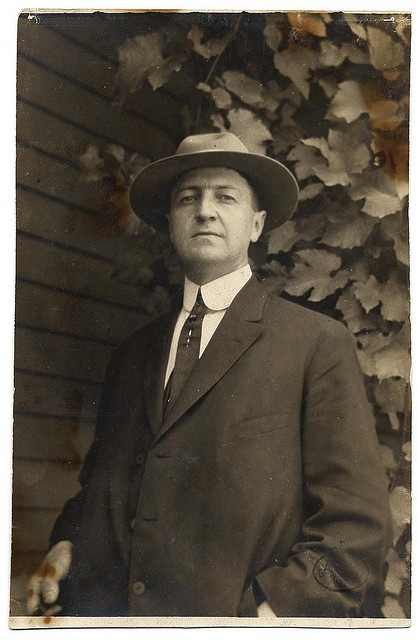Describe the objects in this image and their specific colors. I can see people in white, black, and gray tones and tie in white, black, and gray tones in this image. 